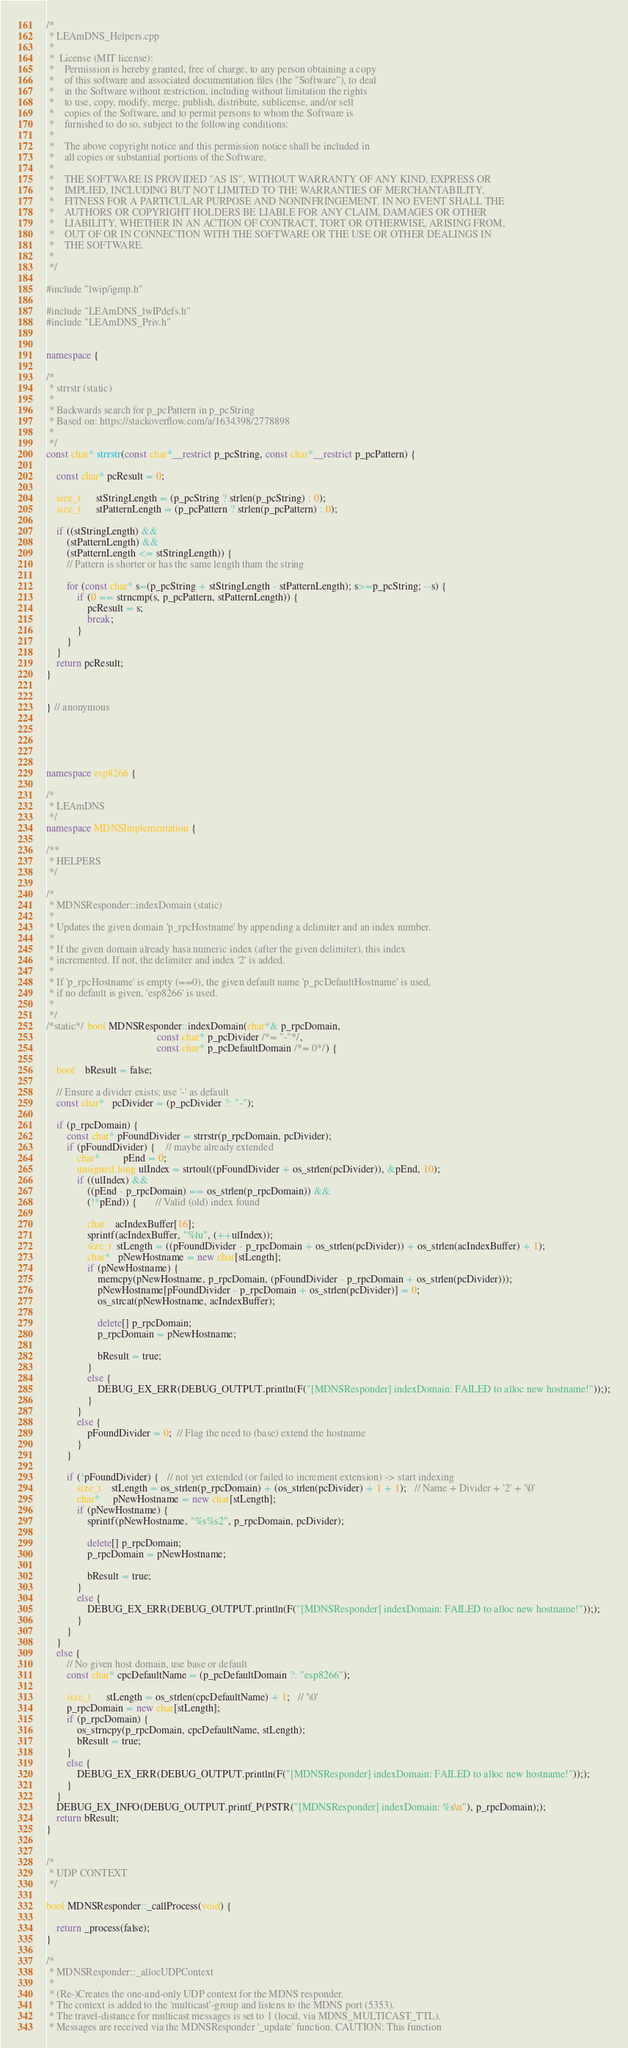Convert code to text. <code><loc_0><loc_0><loc_500><loc_500><_C++_>/*
 * LEAmDNS_Helpers.cpp
 *
 *  License (MIT license):
 *    Permission is hereby granted, free of charge, to any person obtaining a copy
 *    of this software and associated documentation files (the "Software"), to deal
 *    in the Software without restriction, including without limitation the rights
 *    to use, copy, modify, merge, publish, distribute, sublicense, and/or sell
 *    copies of the Software, and to permit persons to whom the Software is
 *    furnished to do so, subject to the following conditions:
 *
 *    The above copyright notice and this permission notice shall be included in
 *    all copies or substantial portions of the Software.
 *
 *    THE SOFTWARE IS PROVIDED "AS IS", WITHOUT WARRANTY OF ANY KIND, EXPRESS OR
 *    IMPLIED, INCLUDING BUT NOT LIMITED TO THE WARRANTIES OF MERCHANTABILITY,
 *    FITNESS FOR A PARTICULAR PURPOSE AND NONINFRINGEMENT. IN NO EVENT SHALL THE
 *    AUTHORS OR COPYRIGHT HOLDERS BE LIABLE FOR ANY CLAIM, DAMAGES OR OTHER
 *    LIABILITY, WHETHER IN AN ACTION OF CONTRACT, TORT OR OTHERWISE, ARISING FROM,
 *    OUT OF OR IN CONNECTION WITH THE SOFTWARE OR THE USE OR OTHER DEALINGS IN
 *    THE SOFTWARE.
 *
 */

#include "lwip/igmp.h"

#include "LEAmDNS_lwIPdefs.h"
#include "LEAmDNS_Priv.h"


namespace {

/*
 * strrstr (static)
 *
 * Backwards search for p_pcPattern in p_pcString
 * Based on: https://stackoverflow.com/a/1634398/2778898
 *
 */
const char* strrstr(const char*__restrict p_pcString, const char*__restrict p_pcPattern) {
    
    const char* pcResult = 0;
    
    size_t      stStringLength = (p_pcString ? strlen(p_pcString) : 0);
    size_t      stPatternLength = (p_pcPattern ? strlen(p_pcPattern) : 0);

    if ((stStringLength) &&
        (stPatternLength) &&
        (stPatternLength <= stStringLength)) {
        // Pattern is shorter or has the same length tham the string
        
        for (const char* s=(p_pcString + stStringLength - stPatternLength); s>=p_pcString; --s) {
            if (0 == strncmp(s, p_pcPattern, stPatternLength)) {
                pcResult = s;
                break;
            }
        }
    }
    return pcResult;
}


} // anonymous





namespace esp8266 {

/*
 * LEAmDNS
 */
namespace MDNSImplementation {

/**
 * HELPERS
 */

/*
 * MDNSResponder::indexDomain (static)
 *
 * Updates the given domain 'p_rpcHostname' by appending a delimiter and an index number.
 *
 * If the given domain already hasa numeric index (after the given delimiter), this index
 * incremented. If not, the delimiter and index '2' is added.
 *
 * If 'p_rpcHostname' is empty (==0), the given default name 'p_pcDefaultHostname' is used,
 * if no default is given, 'esp8266' is used.
 *
 */
/*static*/ bool MDNSResponder::indexDomain(char*& p_rpcDomain,
                                           const char* p_pcDivider /*= "-"*/,
                                           const char* p_pcDefaultDomain /*= 0*/) {

    bool    bResult = false;

    // Ensure a divider exists; use '-' as default
    const char*   pcDivider = (p_pcDivider ?: "-");

    if (p_rpcDomain) {
        const char* pFoundDivider = strrstr(p_rpcDomain, pcDivider);
        if (pFoundDivider) {    // maybe already extended
            char*         pEnd = 0;
            unsigned long ulIndex = strtoul((pFoundDivider + os_strlen(pcDivider)), &pEnd, 10);
            if ((ulIndex) &&
                ((pEnd - p_rpcDomain) == os_strlen(p_rpcDomain)) &&
                (!*pEnd)) {       // Valid (old) index found

                char    acIndexBuffer[16];
                sprintf(acIndexBuffer, "%lu", (++ulIndex));
                size_t  stLength = ((pFoundDivider - p_rpcDomain + os_strlen(pcDivider)) + os_strlen(acIndexBuffer) + 1);
                char*   pNewHostname = new char[stLength];
                if (pNewHostname) {
                    memcpy(pNewHostname, p_rpcDomain, (pFoundDivider - p_rpcDomain + os_strlen(pcDivider)));
                    pNewHostname[pFoundDivider - p_rpcDomain + os_strlen(pcDivider)] = 0;
                    os_strcat(pNewHostname, acIndexBuffer);

                    delete[] p_rpcDomain;
                    p_rpcDomain = pNewHostname;

                    bResult = true;
                }
                else {
                    DEBUG_EX_ERR(DEBUG_OUTPUT.println(F("[MDNSResponder] indexDomain: FAILED to alloc new hostname!")););
                }
            }
            else {
                pFoundDivider = 0;  // Flag the need to (base) extend the hostname
            }
        }

        if (!pFoundDivider) {   // not yet extended (or failed to increment extension) -> start indexing
            size_t    stLength = os_strlen(p_rpcDomain) + (os_strlen(pcDivider) + 1 + 1);   // Name + Divider + '2' + '\0'
            char*     pNewHostname = new char[stLength];
            if (pNewHostname) {
                sprintf(pNewHostname, "%s%s2", p_rpcDomain, pcDivider);

                delete[] p_rpcDomain;
                p_rpcDomain = pNewHostname;

                bResult = true;
            }
            else {
                DEBUG_EX_ERR(DEBUG_OUTPUT.println(F("[MDNSResponder] indexDomain: FAILED to alloc new hostname!")););
            }
        }
    }
    else {
        // No given host domain, use base or default
        const char* cpcDefaultName = (p_pcDefaultDomain ?: "esp8266");

        size_t      stLength = os_strlen(cpcDefaultName) + 1;   // '\0'
        p_rpcDomain = new char[stLength];
        if (p_rpcDomain) {
            os_strncpy(p_rpcDomain, cpcDefaultName, stLength);
            bResult = true;
        }
        else {
            DEBUG_EX_ERR(DEBUG_OUTPUT.println(F("[MDNSResponder] indexDomain: FAILED to alloc new hostname!")););
        }
    }
    DEBUG_EX_INFO(DEBUG_OUTPUT.printf_P(PSTR("[MDNSResponder] indexDomain: %s\n"), p_rpcDomain););
    return bResult;
}


/*
 * UDP CONTEXT
 */

bool MDNSResponder::_callProcess(void) {

    return _process(false);
}

/*
 * MDNSResponder::_allocUDPContext
 *
 * (Re-)Creates the one-and-only UDP context for the MDNS responder.
 * The context is added to the 'multicast'-group and listens to the MDNS port (5353).
 * The travel-distance for multicast messages is set to 1 (local, via MDNS_MULTICAST_TTL).
 * Messages are received via the MDNSResponder '_update' function. CAUTION: This function</code> 